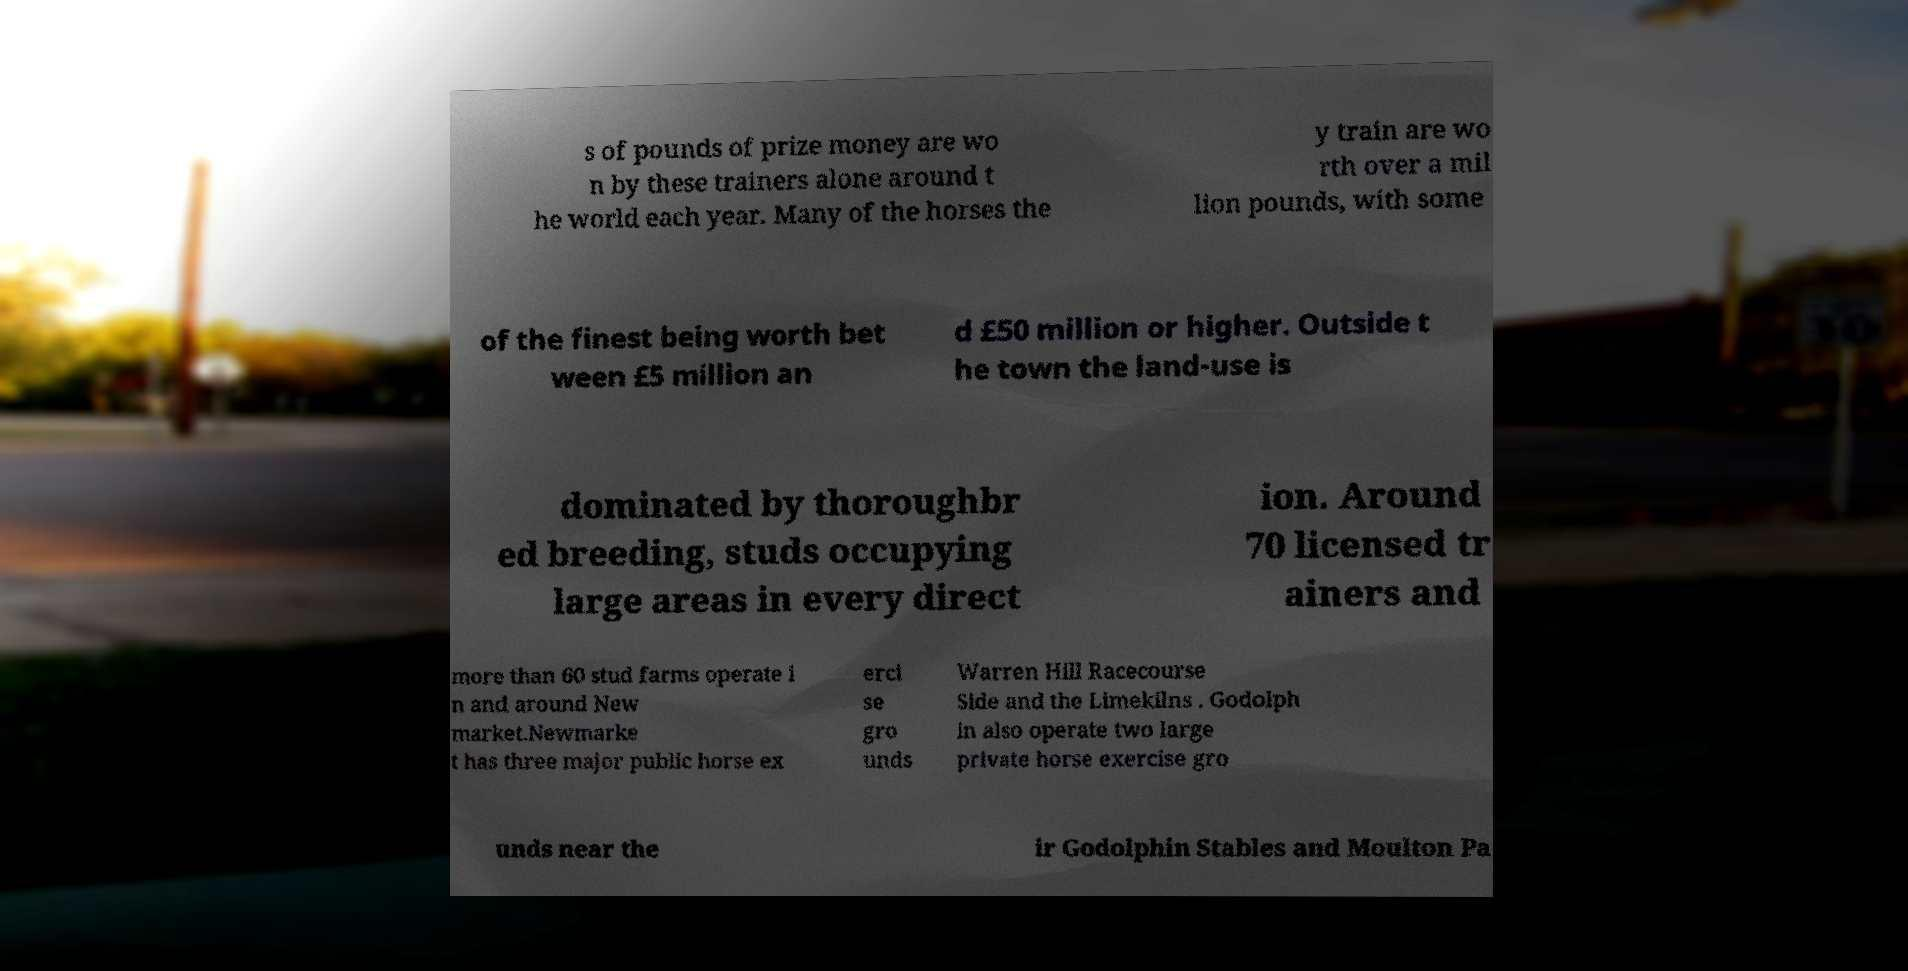For documentation purposes, I need the text within this image transcribed. Could you provide that? s of pounds of prize money are wo n by these trainers alone around t he world each year. Many of the horses the y train are wo rth over a mil lion pounds, with some of the finest being worth bet ween £5 million an d £50 million or higher. Outside t he town the land-use is dominated by thoroughbr ed breeding, studs occupying large areas in every direct ion. Around 70 licensed tr ainers and more than 60 stud farms operate i n and around New market.Newmarke t has three major public horse ex erci se gro unds Warren Hill Racecourse Side and the Limekilns . Godolph in also operate two large private horse exercise gro unds near the ir Godolphin Stables and Moulton Pa 